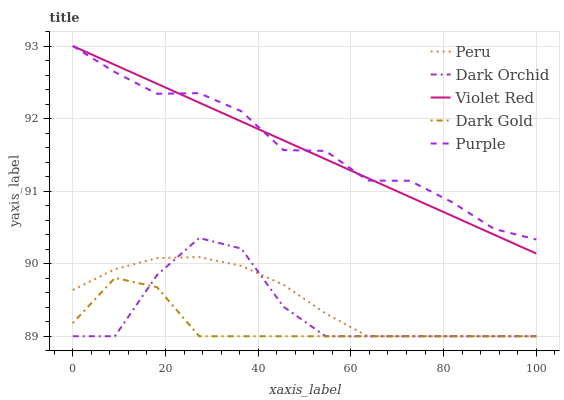Does Dark Gold have the minimum area under the curve?
Answer yes or no. Yes. Does Purple have the maximum area under the curve?
Answer yes or no. Yes. Does Violet Red have the minimum area under the curve?
Answer yes or no. No. Does Violet Red have the maximum area under the curve?
Answer yes or no. No. Is Violet Red the smoothest?
Answer yes or no. Yes. Is Dark Orchid the roughest?
Answer yes or no. Yes. Is Dark Orchid the smoothest?
Answer yes or no. No. Is Violet Red the roughest?
Answer yes or no. No. Does Dark Orchid have the lowest value?
Answer yes or no. Yes. Does Violet Red have the lowest value?
Answer yes or no. No. Does Violet Red have the highest value?
Answer yes or no. Yes. Does Dark Orchid have the highest value?
Answer yes or no. No. Is Peru less than Violet Red?
Answer yes or no. Yes. Is Violet Red greater than Dark Gold?
Answer yes or no. Yes. Does Violet Red intersect Purple?
Answer yes or no. Yes. Is Violet Red less than Purple?
Answer yes or no. No. Is Violet Red greater than Purple?
Answer yes or no. No. Does Peru intersect Violet Red?
Answer yes or no. No. 